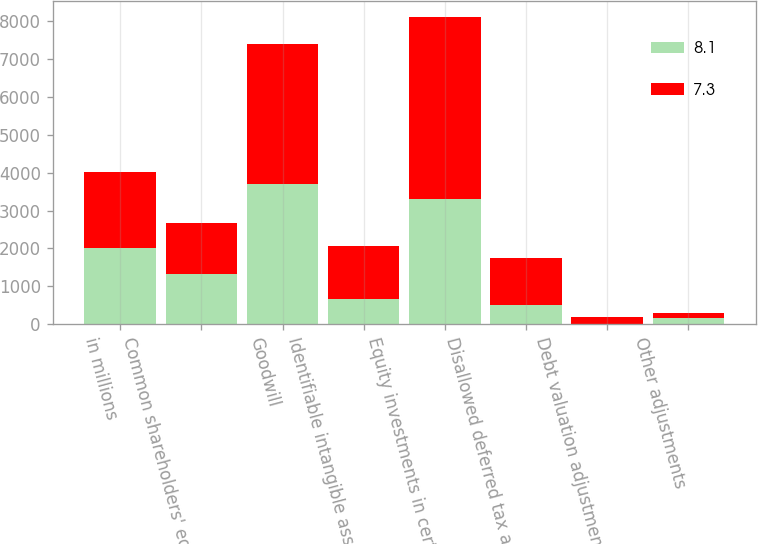<chart> <loc_0><loc_0><loc_500><loc_500><stacked_bar_chart><ecel><fcel>in millions<fcel>Common shareholders' equity<fcel>Goodwill<fcel>Identifiable intangible assets<fcel>Equity investments in certain<fcel>Disallowed deferred tax assets<fcel>Debt valuation adjustment<fcel>Other adjustments<nl><fcel>8.1<fcel>2013<fcel>1329<fcel>3705<fcel>671<fcel>3314<fcel>498<fcel>10<fcel>159<nl><fcel>7.3<fcel>2012<fcel>1329<fcel>3702<fcel>1397<fcel>4805<fcel>1261<fcel>180<fcel>124<nl></chart> 